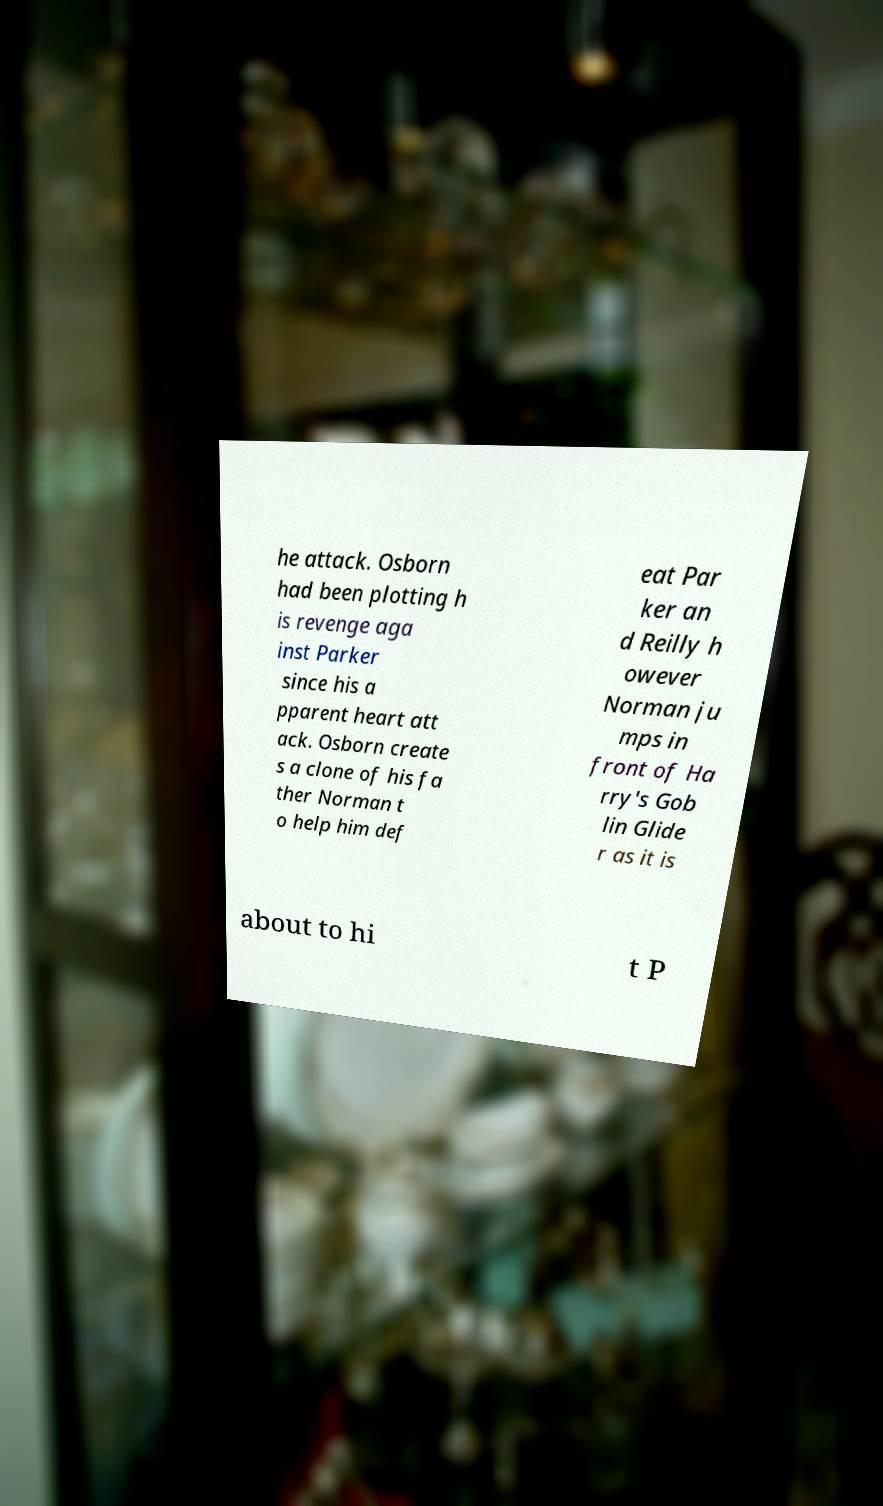Can you accurately transcribe the text from the provided image for me? he attack. Osborn had been plotting h is revenge aga inst Parker since his a pparent heart att ack. Osborn create s a clone of his fa ther Norman t o help him def eat Par ker an d Reilly h owever Norman ju mps in front of Ha rry's Gob lin Glide r as it is about to hi t P 